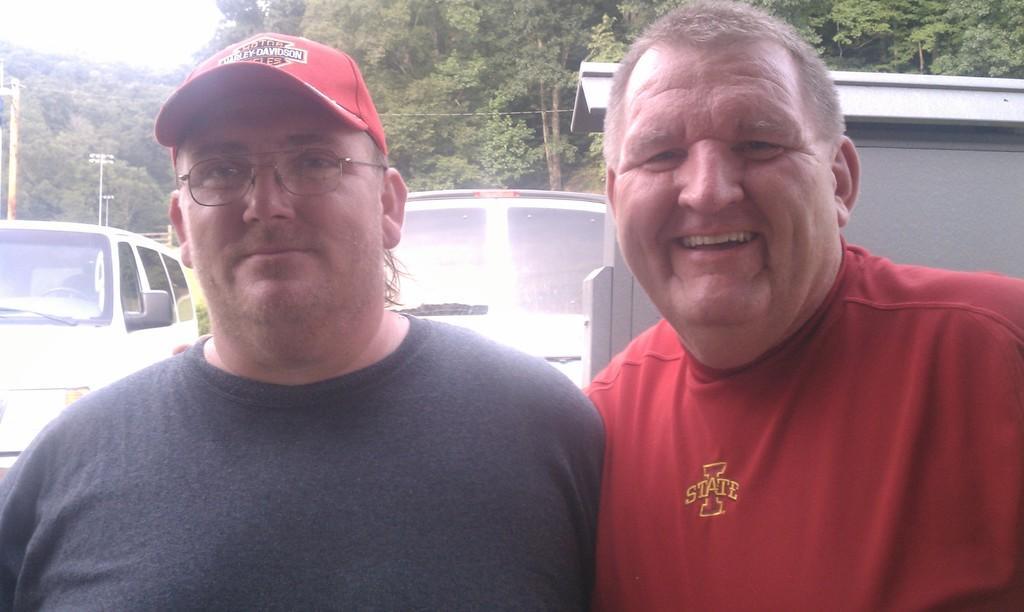In one or two sentences, can you explain what this image depicts? In the picture there are two men standing one beside another and behind these people there are two vehicles and in the background there are lot of trees. 